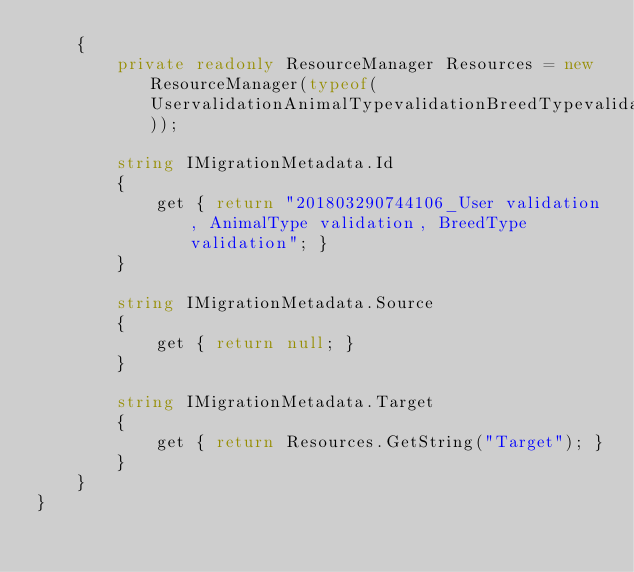<code> <loc_0><loc_0><loc_500><loc_500><_C#_>    {
        private readonly ResourceManager Resources = new ResourceManager(typeof(UservalidationAnimalTypevalidationBreedTypevalidation));
        
        string IMigrationMetadata.Id
        {
            get { return "201803290744106_User validation, AnimalType validation, BreedType validation"; }
        }
        
        string IMigrationMetadata.Source
        {
            get { return null; }
        }
        
        string IMigrationMetadata.Target
        {
            get { return Resources.GetString("Target"); }
        }
    }
}
</code> 